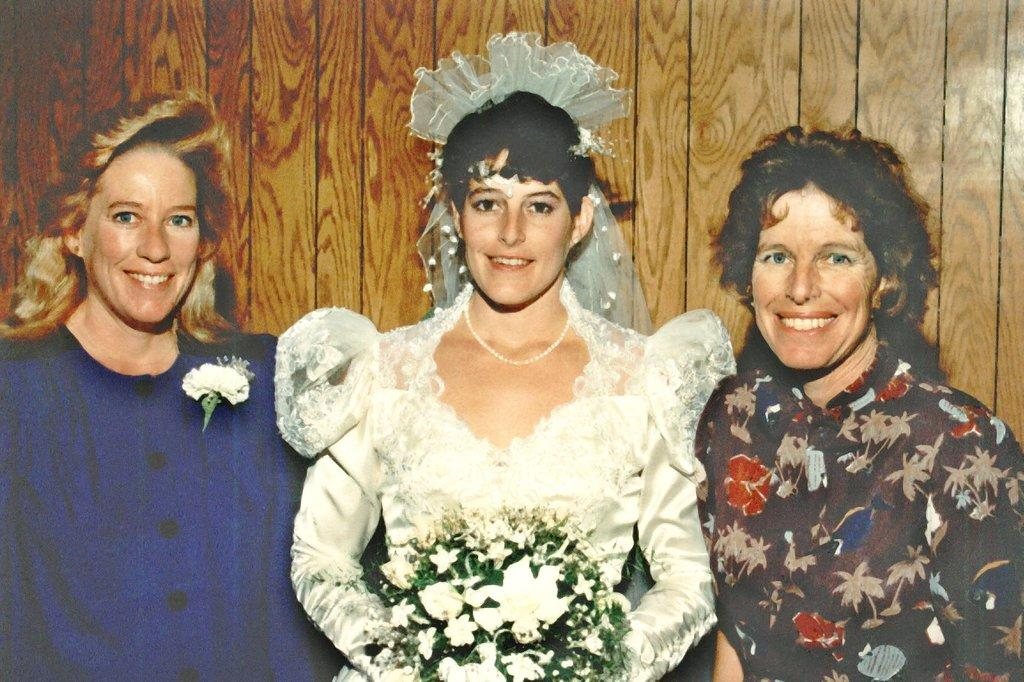How many persons are in the image? There are persons in the image, but the exact number is not specified. What are the persons wearing? The persons are wearing clothes. What type of material is the wall made of in the image? There is a wooden wall in the image. What type of feather can be seen on the expert's hat in the image? There is no expert or hat present in the image, and therefore no feather can be observed. What type of drink is being consumed by the persons in the image? The provided facts do not mention any drinks being consumed by the persons in the image. 